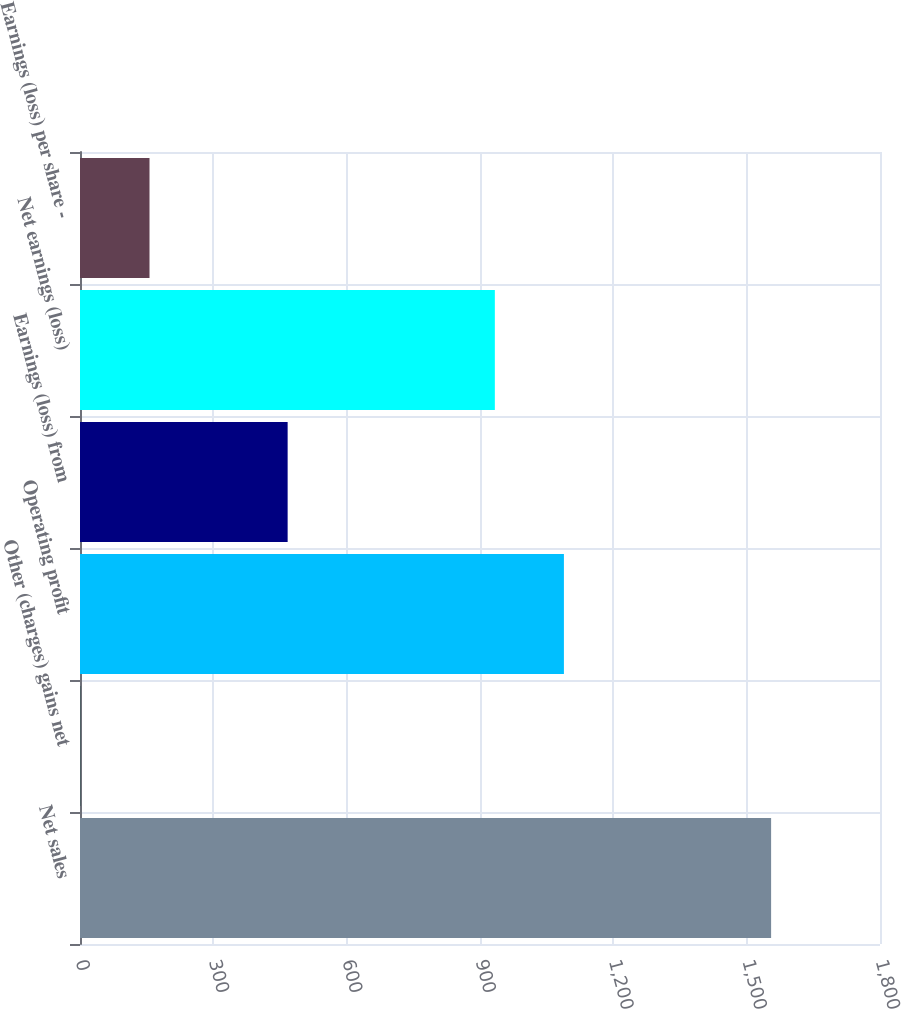Convert chart. <chart><loc_0><loc_0><loc_500><loc_500><bar_chart><fcel>Net sales<fcel>Other (charges) gains net<fcel>Operating profit<fcel>Earnings (loss) from<fcel>Net earnings (loss)<fcel>Earnings (loss) per share -<nl><fcel>1555<fcel>1<fcel>1088.8<fcel>467.2<fcel>933.4<fcel>156.4<nl></chart> 